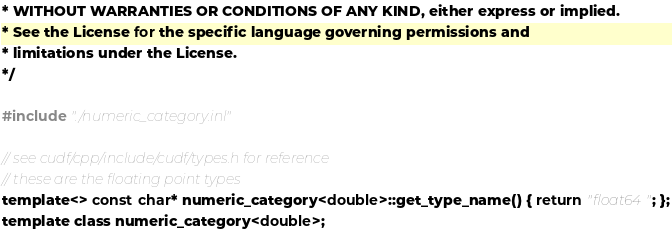Convert code to text. <code><loc_0><loc_0><loc_500><loc_500><_Cuda_>* WITHOUT WARRANTIES OR CONDITIONS OF ANY KIND, either express or implied.
* See the License for the specific language governing permissions and
* limitations under the License.
*/

#include "./numeric_category.inl"

// see cudf/cpp/include/cudf/types.h for reference
// these are the floating point types
template<> const char* numeric_category<double>::get_type_name() { return "float64"; };
template class numeric_category<double>;

</code> 